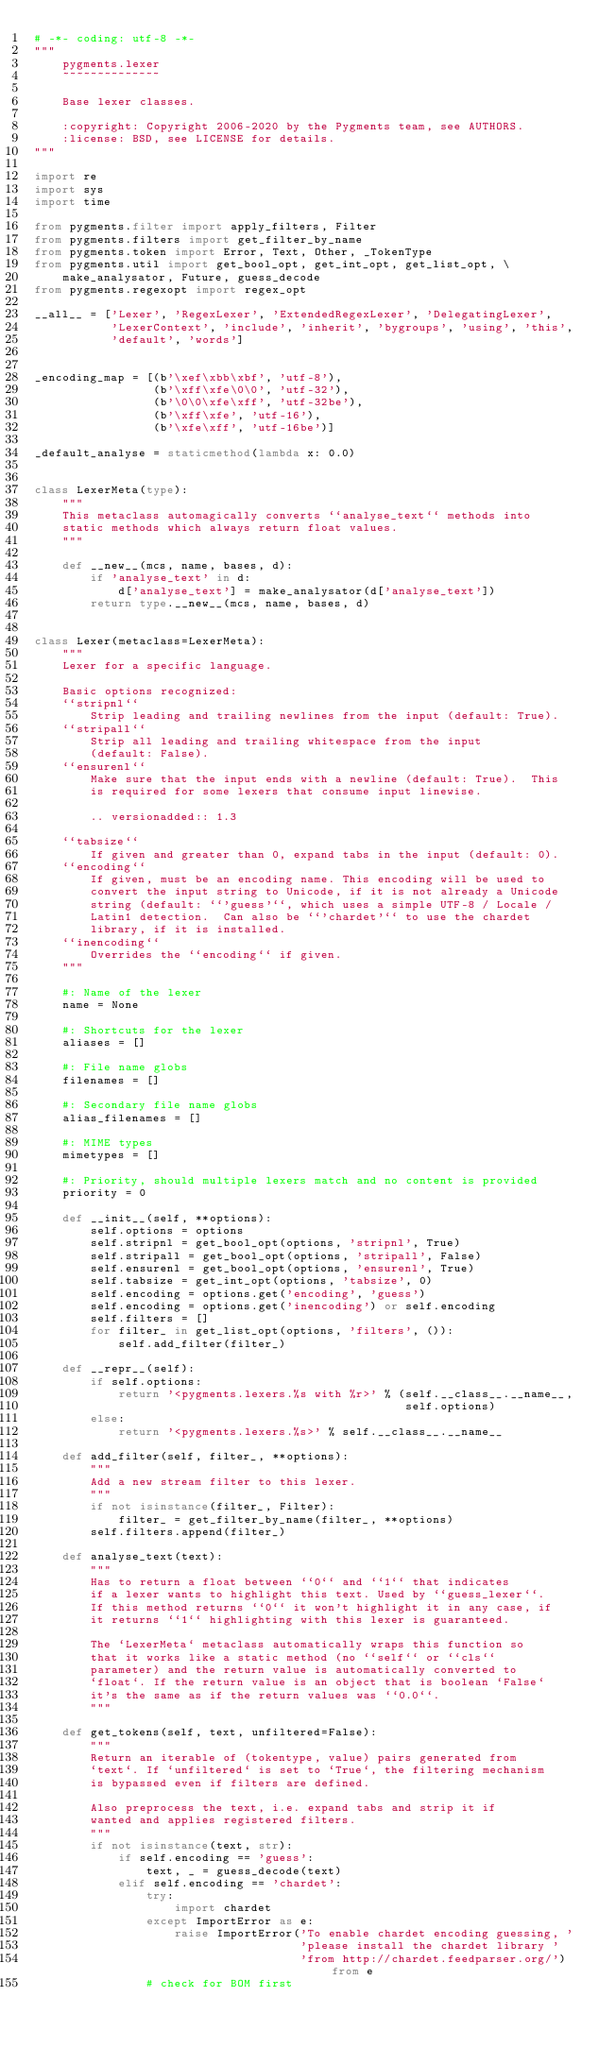<code> <loc_0><loc_0><loc_500><loc_500><_Python_># -*- coding: utf-8 -*-
"""
    pygments.lexer
    ~~~~~~~~~~~~~~

    Base lexer classes.

    :copyright: Copyright 2006-2020 by the Pygments team, see AUTHORS.
    :license: BSD, see LICENSE for details.
"""

import re
import sys
import time

from pygments.filter import apply_filters, Filter
from pygments.filters import get_filter_by_name
from pygments.token import Error, Text, Other, _TokenType
from pygments.util import get_bool_opt, get_int_opt, get_list_opt, \
    make_analysator, Future, guess_decode
from pygments.regexopt import regex_opt

__all__ = ['Lexer', 'RegexLexer', 'ExtendedRegexLexer', 'DelegatingLexer',
           'LexerContext', 'include', 'inherit', 'bygroups', 'using', 'this',
           'default', 'words']


_encoding_map = [(b'\xef\xbb\xbf', 'utf-8'),
                 (b'\xff\xfe\0\0', 'utf-32'),
                 (b'\0\0\xfe\xff', 'utf-32be'),
                 (b'\xff\xfe', 'utf-16'),
                 (b'\xfe\xff', 'utf-16be')]

_default_analyse = staticmethod(lambda x: 0.0)


class LexerMeta(type):
    """
    This metaclass automagically converts ``analyse_text`` methods into
    static methods which always return float values.
    """

    def __new__(mcs, name, bases, d):
        if 'analyse_text' in d:
            d['analyse_text'] = make_analysator(d['analyse_text'])
        return type.__new__(mcs, name, bases, d)


class Lexer(metaclass=LexerMeta):
    """
    Lexer for a specific language.

    Basic options recognized:
    ``stripnl``
        Strip leading and trailing newlines from the input (default: True).
    ``stripall``
        Strip all leading and trailing whitespace from the input
        (default: False).
    ``ensurenl``
        Make sure that the input ends with a newline (default: True).  This
        is required for some lexers that consume input linewise.

        .. versionadded:: 1.3

    ``tabsize``
        If given and greater than 0, expand tabs in the input (default: 0).
    ``encoding``
        If given, must be an encoding name. This encoding will be used to
        convert the input string to Unicode, if it is not already a Unicode
        string (default: ``'guess'``, which uses a simple UTF-8 / Locale /
        Latin1 detection.  Can also be ``'chardet'`` to use the chardet
        library, if it is installed.
    ``inencoding``
        Overrides the ``encoding`` if given.
    """

    #: Name of the lexer
    name = None

    #: Shortcuts for the lexer
    aliases = []

    #: File name globs
    filenames = []

    #: Secondary file name globs
    alias_filenames = []

    #: MIME types
    mimetypes = []

    #: Priority, should multiple lexers match and no content is provided
    priority = 0

    def __init__(self, **options):
        self.options = options
        self.stripnl = get_bool_opt(options, 'stripnl', True)
        self.stripall = get_bool_opt(options, 'stripall', False)
        self.ensurenl = get_bool_opt(options, 'ensurenl', True)
        self.tabsize = get_int_opt(options, 'tabsize', 0)
        self.encoding = options.get('encoding', 'guess')
        self.encoding = options.get('inencoding') or self.encoding
        self.filters = []
        for filter_ in get_list_opt(options, 'filters', ()):
            self.add_filter(filter_)

    def __repr__(self):
        if self.options:
            return '<pygments.lexers.%s with %r>' % (self.__class__.__name__,
                                                     self.options)
        else:
            return '<pygments.lexers.%s>' % self.__class__.__name__

    def add_filter(self, filter_, **options):
        """
        Add a new stream filter to this lexer.
        """
        if not isinstance(filter_, Filter):
            filter_ = get_filter_by_name(filter_, **options)
        self.filters.append(filter_)

    def analyse_text(text):
        """
        Has to return a float between ``0`` and ``1`` that indicates
        if a lexer wants to highlight this text. Used by ``guess_lexer``.
        If this method returns ``0`` it won't highlight it in any case, if
        it returns ``1`` highlighting with this lexer is guaranteed.

        The `LexerMeta` metaclass automatically wraps this function so
        that it works like a static method (no ``self`` or ``cls``
        parameter) and the return value is automatically converted to
        `float`. If the return value is an object that is boolean `False`
        it's the same as if the return values was ``0.0``.
        """

    def get_tokens(self, text, unfiltered=False):
        """
        Return an iterable of (tokentype, value) pairs generated from
        `text`. If `unfiltered` is set to `True`, the filtering mechanism
        is bypassed even if filters are defined.

        Also preprocess the text, i.e. expand tabs and strip it if
        wanted and applies registered filters.
        """
        if not isinstance(text, str):
            if self.encoding == 'guess':
                text, _ = guess_decode(text)
            elif self.encoding == 'chardet':
                try:
                    import chardet
                except ImportError as e:
                    raise ImportError('To enable chardet encoding guessing, '
                                      'please install the chardet library '
                                      'from http://chardet.feedparser.org/') from e
                # check for BOM first</code> 